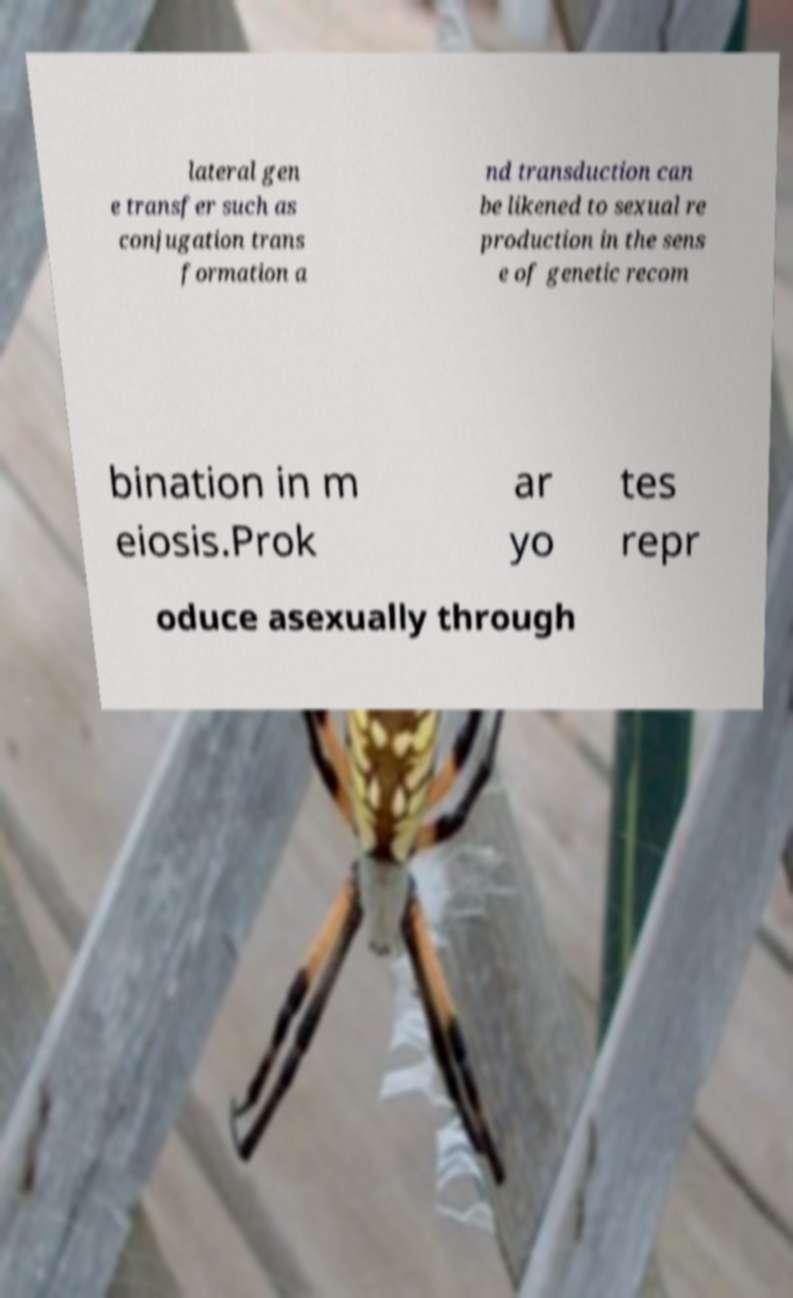There's text embedded in this image that I need extracted. Can you transcribe it verbatim? lateral gen e transfer such as conjugation trans formation a nd transduction can be likened to sexual re production in the sens e of genetic recom bination in m eiosis.Prok ar yo tes repr oduce asexually through 